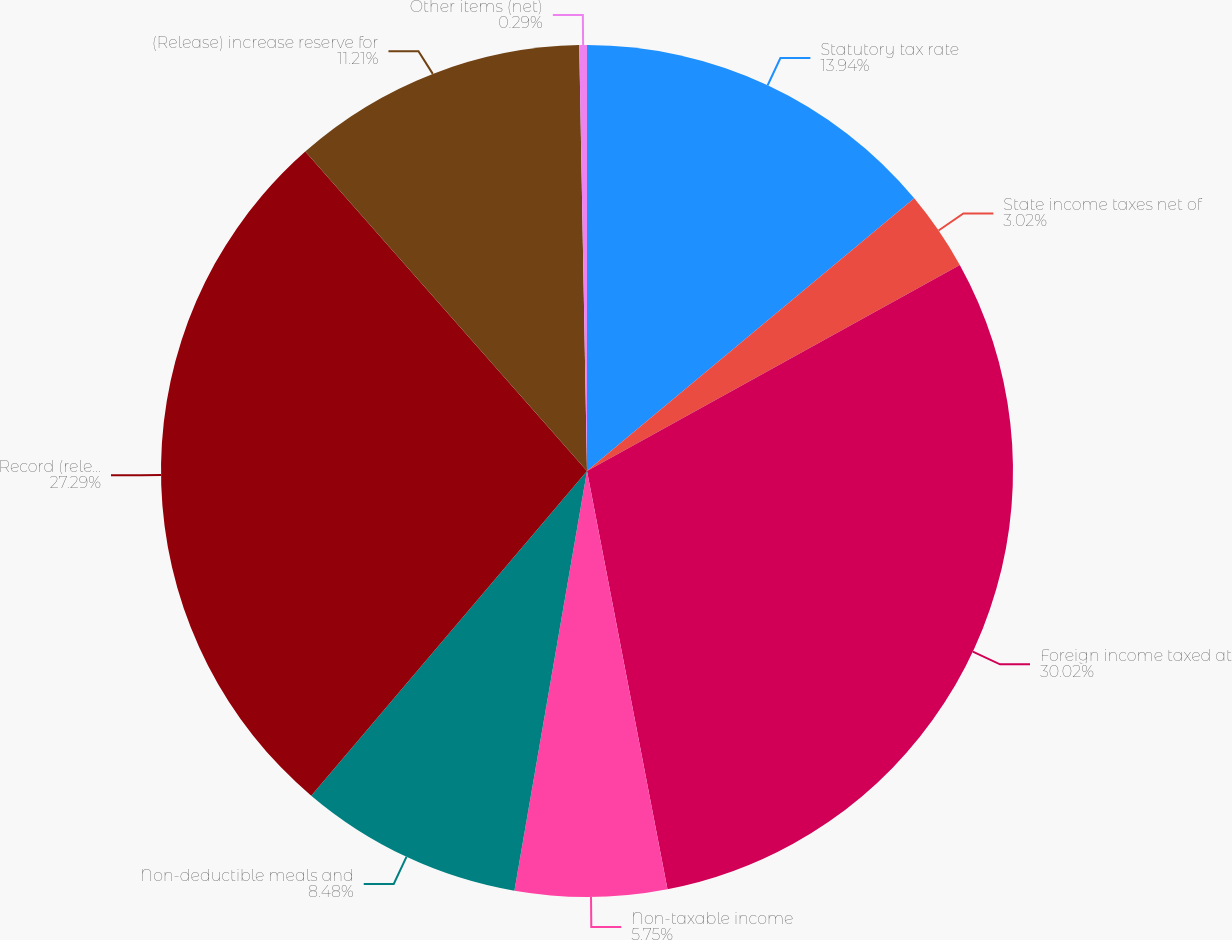Convert chart. <chart><loc_0><loc_0><loc_500><loc_500><pie_chart><fcel>Statutory tax rate<fcel>State income taxes net of<fcel>Foreign income taxed at<fcel>Non-taxable income<fcel>Non-deductible meals and<fcel>Record (release) valuation<fcel>(Release) increase reserve for<fcel>Other items (net)<nl><fcel>13.94%<fcel>3.02%<fcel>30.01%<fcel>5.75%<fcel>8.48%<fcel>27.29%<fcel>11.21%<fcel>0.29%<nl></chart> 